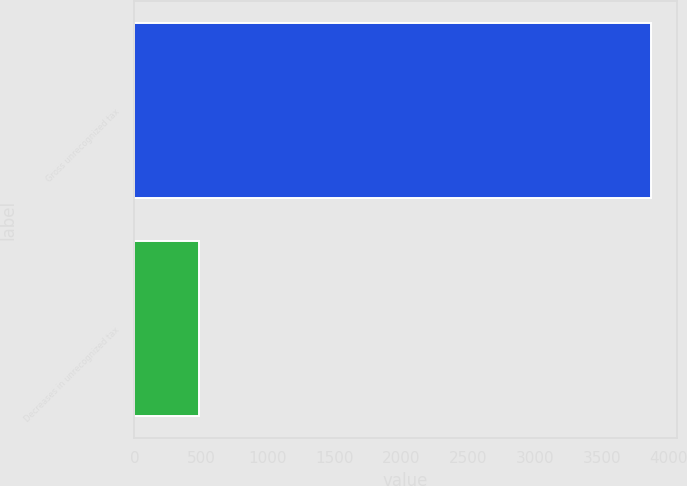<chart> <loc_0><loc_0><loc_500><loc_500><bar_chart><fcel>Gross unrecognized tax<fcel>Decreases in unrecognized tax<nl><fcel>3869<fcel>487<nl></chart> 